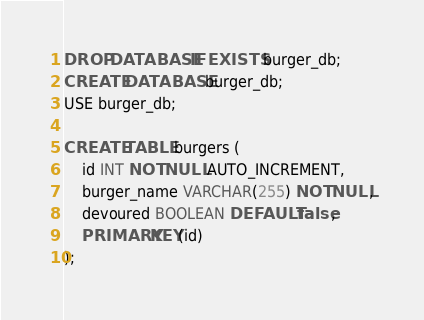<code> <loc_0><loc_0><loc_500><loc_500><_SQL_>DROP DATABASE IF EXISTS burger_db;
CREATE DATABASE burger_db;
USE burger_db;

CREATE TABLE burgers (
    id INT NOT NULL AUTO_INCREMENT,
    burger_name VARCHAR(255) NOT NULL,
    devoured BOOLEAN DEFAULT false,
    PRIMARY KEY(id)
);
</code> 